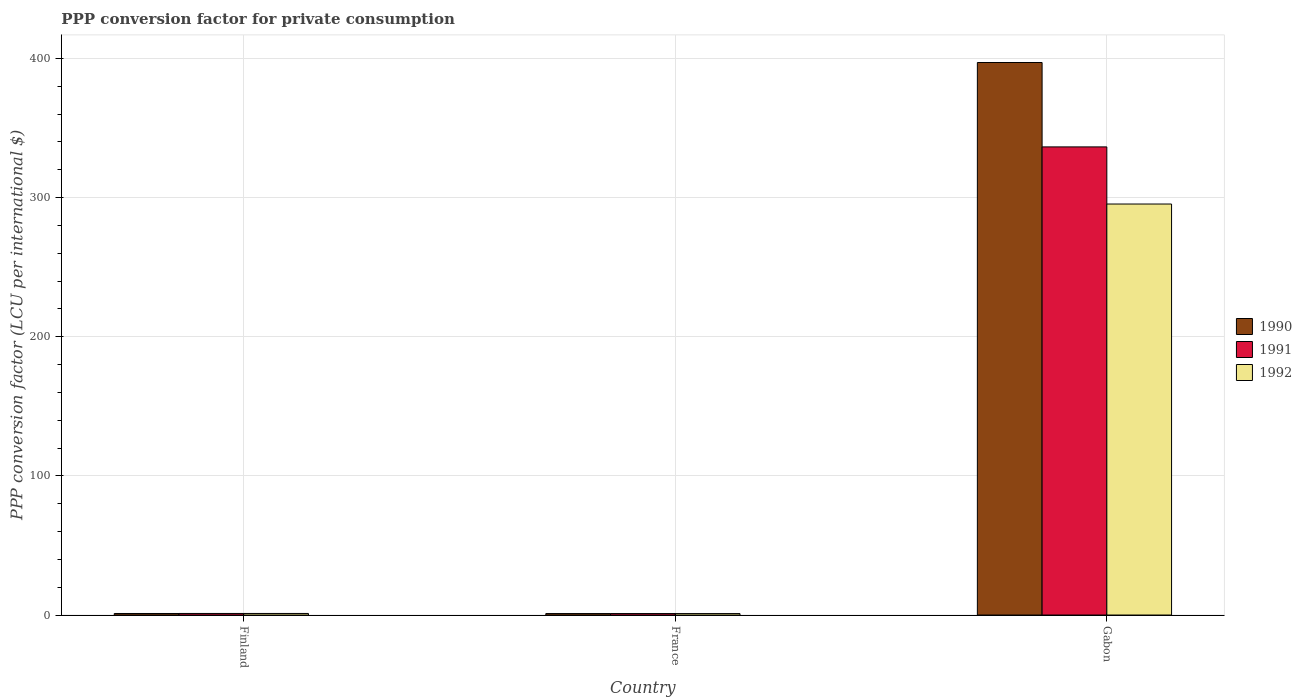Are the number of bars on each tick of the X-axis equal?
Provide a short and direct response. Yes. How many bars are there on the 3rd tick from the right?
Provide a succinct answer. 3. What is the label of the 1st group of bars from the left?
Your answer should be very brief. Finland. In how many cases, is the number of bars for a given country not equal to the number of legend labels?
Give a very brief answer. 0. What is the PPP conversion factor for private consumption in 1991 in Finland?
Offer a very short reply. 1.12. Across all countries, what is the maximum PPP conversion factor for private consumption in 1991?
Provide a succinct answer. 336.44. Across all countries, what is the minimum PPP conversion factor for private consumption in 1990?
Your response must be concise. 1.06. In which country was the PPP conversion factor for private consumption in 1990 maximum?
Keep it short and to the point. Gabon. In which country was the PPP conversion factor for private consumption in 1990 minimum?
Offer a terse response. France. What is the total PPP conversion factor for private consumption in 1991 in the graph?
Provide a short and direct response. 338.61. What is the difference between the PPP conversion factor for private consumption in 1991 in Finland and that in France?
Keep it short and to the point. 0.07. What is the difference between the PPP conversion factor for private consumption in 1991 in France and the PPP conversion factor for private consumption in 1990 in Gabon?
Ensure brevity in your answer.  -396.05. What is the average PPP conversion factor for private consumption in 1990 per country?
Keep it short and to the point. 133.08. What is the difference between the PPP conversion factor for private consumption of/in 1991 and PPP conversion factor for private consumption of/in 1990 in Gabon?
Your answer should be compact. -60.65. In how many countries, is the PPP conversion factor for private consumption in 1990 greater than 380 LCU?
Provide a succinct answer. 1. What is the ratio of the PPP conversion factor for private consumption in 1990 in Finland to that in Gabon?
Make the answer very short. 0. Is the difference between the PPP conversion factor for private consumption in 1991 in France and Gabon greater than the difference between the PPP conversion factor for private consumption in 1990 in France and Gabon?
Give a very brief answer. Yes. What is the difference between the highest and the second highest PPP conversion factor for private consumption in 1991?
Make the answer very short. 335.33. What is the difference between the highest and the lowest PPP conversion factor for private consumption in 1990?
Give a very brief answer. 396.04. What does the 1st bar from the left in France represents?
Give a very brief answer. 1990. What does the 3rd bar from the right in France represents?
Offer a terse response. 1990. Are all the bars in the graph horizontal?
Your answer should be very brief. No. How many countries are there in the graph?
Provide a short and direct response. 3. What is the difference between two consecutive major ticks on the Y-axis?
Your answer should be very brief. 100. Are the values on the major ticks of Y-axis written in scientific E-notation?
Offer a terse response. No. Does the graph contain any zero values?
Give a very brief answer. No. Does the graph contain grids?
Make the answer very short. Yes. Where does the legend appear in the graph?
Your answer should be compact. Center right. What is the title of the graph?
Provide a short and direct response. PPP conversion factor for private consumption. Does "2000" appear as one of the legend labels in the graph?
Offer a terse response. No. What is the label or title of the X-axis?
Provide a short and direct response. Country. What is the label or title of the Y-axis?
Your answer should be compact. PPP conversion factor (LCU per international $). What is the PPP conversion factor (LCU per international $) in 1990 in Finland?
Make the answer very short. 1.1. What is the PPP conversion factor (LCU per international $) in 1991 in Finland?
Your answer should be compact. 1.12. What is the PPP conversion factor (LCU per international $) of 1992 in Finland?
Give a very brief answer. 1.13. What is the PPP conversion factor (LCU per international $) in 1990 in France?
Ensure brevity in your answer.  1.06. What is the PPP conversion factor (LCU per international $) in 1991 in France?
Your response must be concise. 1.05. What is the PPP conversion factor (LCU per international $) of 1992 in France?
Offer a terse response. 1.05. What is the PPP conversion factor (LCU per international $) in 1990 in Gabon?
Keep it short and to the point. 397.1. What is the PPP conversion factor (LCU per international $) in 1991 in Gabon?
Your answer should be compact. 336.44. What is the PPP conversion factor (LCU per international $) of 1992 in Gabon?
Keep it short and to the point. 295.39. Across all countries, what is the maximum PPP conversion factor (LCU per international $) of 1990?
Ensure brevity in your answer.  397.1. Across all countries, what is the maximum PPP conversion factor (LCU per international $) of 1991?
Ensure brevity in your answer.  336.44. Across all countries, what is the maximum PPP conversion factor (LCU per international $) of 1992?
Your response must be concise. 295.39. Across all countries, what is the minimum PPP conversion factor (LCU per international $) of 1990?
Your answer should be compact. 1.06. Across all countries, what is the minimum PPP conversion factor (LCU per international $) of 1991?
Make the answer very short. 1.05. Across all countries, what is the minimum PPP conversion factor (LCU per international $) of 1992?
Provide a succinct answer. 1.05. What is the total PPP conversion factor (LCU per international $) of 1990 in the graph?
Offer a terse response. 399.25. What is the total PPP conversion factor (LCU per international $) of 1991 in the graph?
Your response must be concise. 338.61. What is the total PPP conversion factor (LCU per international $) of 1992 in the graph?
Provide a short and direct response. 297.57. What is the difference between the PPP conversion factor (LCU per international $) of 1990 in Finland and that in France?
Ensure brevity in your answer.  0.05. What is the difference between the PPP conversion factor (LCU per international $) in 1991 in Finland and that in France?
Your answer should be compact. 0.07. What is the difference between the PPP conversion factor (LCU per international $) in 1992 in Finland and that in France?
Offer a terse response. 0.08. What is the difference between the PPP conversion factor (LCU per international $) of 1990 in Finland and that in Gabon?
Ensure brevity in your answer.  -396. What is the difference between the PPP conversion factor (LCU per international $) in 1991 in Finland and that in Gabon?
Your answer should be compact. -335.33. What is the difference between the PPP conversion factor (LCU per international $) in 1992 in Finland and that in Gabon?
Keep it short and to the point. -294.26. What is the difference between the PPP conversion factor (LCU per international $) in 1990 in France and that in Gabon?
Keep it short and to the point. -396.04. What is the difference between the PPP conversion factor (LCU per international $) of 1991 in France and that in Gabon?
Offer a terse response. -335.39. What is the difference between the PPP conversion factor (LCU per international $) of 1992 in France and that in Gabon?
Your answer should be very brief. -294.34. What is the difference between the PPP conversion factor (LCU per international $) in 1990 in Finland and the PPP conversion factor (LCU per international $) in 1991 in France?
Offer a terse response. 0.05. What is the difference between the PPP conversion factor (LCU per international $) in 1990 in Finland and the PPP conversion factor (LCU per international $) in 1992 in France?
Provide a succinct answer. 0.05. What is the difference between the PPP conversion factor (LCU per international $) in 1991 in Finland and the PPP conversion factor (LCU per international $) in 1992 in France?
Keep it short and to the point. 0.07. What is the difference between the PPP conversion factor (LCU per international $) of 1990 in Finland and the PPP conversion factor (LCU per international $) of 1991 in Gabon?
Keep it short and to the point. -335.34. What is the difference between the PPP conversion factor (LCU per international $) in 1990 in Finland and the PPP conversion factor (LCU per international $) in 1992 in Gabon?
Your answer should be compact. -294.29. What is the difference between the PPP conversion factor (LCU per international $) in 1991 in Finland and the PPP conversion factor (LCU per international $) in 1992 in Gabon?
Offer a very short reply. -294.27. What is the difference between the PPP conversion factor (LCU per international $) of 1990 in France and the PPP conversion factor (LCU per international $) of 1991 in Gabon?
Provide a succinct answer. -335.39. What is the difference between the PPP conversion factor (LCU per international $) of 1990 in France and the PPP conversion factor (LCU per international $) of 1992 in Gabon?
Your response must be concise. -294.33. What is the difference between the PPP conversion factor (LCU per international $) of 1991 in France and the PPP conversion factor (LCU per international $) of 1992 in Gabon?
Offer a terse response. -294.34. What is the average PPP conversion factor (LCU per international $) of 1990 per country?
Give a very brief answer. 133.08. What is the average PPP conversion factor (LCU per international $) in 1991 per country?
Your answer should be very brief. 112.87. What is the average PPP conversion factor (LCU per international $) in 1992 per country?
Your response must be concise. 99.19. What is the difference between the PPP conversion factor (LCU per international $) of 1990 and PPP conversion factor (LCU per international $) of 1991 in Finland?
Offer a terse response. -0.02. What is the difference between the PPP conversion factor (LCU per international $) in 1990 and PPP conversion factor (LCU per international $) in 1992 in Finland?
Your response must be concise. -0.03. What is the difference between the PPP conversion factor (LCU per international $) in 1991 and PPP conversion factor (LCU per international $) in 1992 in Finland?
Make the answer very short. -0.01. What is the difference between the PPP conversion factor (LCU per international $) in 1990 and PPP conversion factor (LCU per international $) in 1991 in France?
Your response must be concise. 0.01. What is the difference between the PPP conversion factor (LCU per international $) in 1990 and PPP conversion factor (LCU per international $) in 1992 in France?
Give a very brief answer. 0.01. What is the difference between the PPP conversion factor (LCU per international $) of 1991 and PPP conversion factor (LCU per international $) of 1992 in France?
Your answer should be very brief. 0. What is the difference between the PPP conversion factor (LCU per international $) in 1990 and PPP conversion factor (LCU per international $) in 1991 in Gabon?
Your response must be concise. 60.65. What is the difference between the PPP conversion factor (LCU per international $) of 1990 and PPP conversion factor (LCU per international $) of 1992 in Gabon?
Make the answer very short. 101.71. What is the difference between the PPP conversion factor (LCU per international $) in 1991 and PPP conversion factor (LCU per international $) in 1992 in Gabon?
Your answer should be very brief. 41.05. What is the ratio of the PPP conversion factor (LCU per international $) of 1990 in Finland to that in France?
Offer a terse response. 1.04. What is the ratio of the PPP conversion factor (LCU per international $) of 1991 in Finland to that in France?
Provide a short and direct response. 1.06. What is the ratio of the PPP conversion factor (LCU per international $) in 1992 in Finland to that in France?
Your answer should be compact. 1.07. What is the ratio of the PPP conversion factor (LCU per international $) in 1990 in Finland to that in Gabon?
Your response must be concise. 0. What is the ratio of the PPP conversion factor (LCU per international $) of 1991 in Finland to that in Gabon?
Your answer should be compact. 0. What is the ratio of the PPP conversion factor (LCU per international $) in 1992 in Finland to that in Gabon?
Provide a short and direct response. 0. What is the ratio of the PPP conversion factor (LCU per international $) of 1990 in France to that in Gabon?
Ensure brevity in your answer.  0. What is the ratio of the PPP conversion factor (LCU per international $) in 1991 in France to that in Gabon?
Ensure brevity in your answer.  0. What is the ratio of the PPP conversion factor (LCU per international $) of 1992 in France to that in Gabon?
Provide a succinct answer. 0. What is the difference between the highest and the second highest PPP conversion factor (LCU per international $) of 1990?
Ensure brevity in your answer.  396. What is the difference between the highest and the second highest PPP conversion factor (LCU per international $) in 1991?
Your answer should be very brief. 335.33. What is the difference between the highest and the second highest PPP conversion factor (LCU per international $) in 1992?
Provide a short and direct response. 294.26. What is the difference between the highest and the lowest PPP conversion factor (LCU per international $) of 1990?
Provide a succinct answer. 396.04. What is the difference between the highest and the lowest PPP conversion factor (LCU per international $) of 1991?
Offer a terse response. 335.39. What is the difference between the highest and the lowest PPP conversion factor (LCU per international $) of 1992?
Provide a succinct answer. 294.34. 